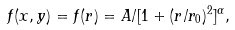Convert formula to latex. <formula><loc_0><loc_0><loc_500><loc_500>f ( x , y ) = f ( r ) = A / [ 1 + ( r / r _ { 0 } ) ^ { 2 } ] ^ { \alpha } ,</formula> 